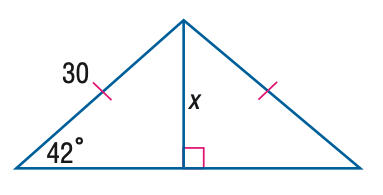Answer the mathemtical geometry problem and directly provide the correct option letter.
Question: Find x. Round to the nearest tenth.
Choices: A: 20.1 B: 21.2 C: 22.3 D: 23.4 A 